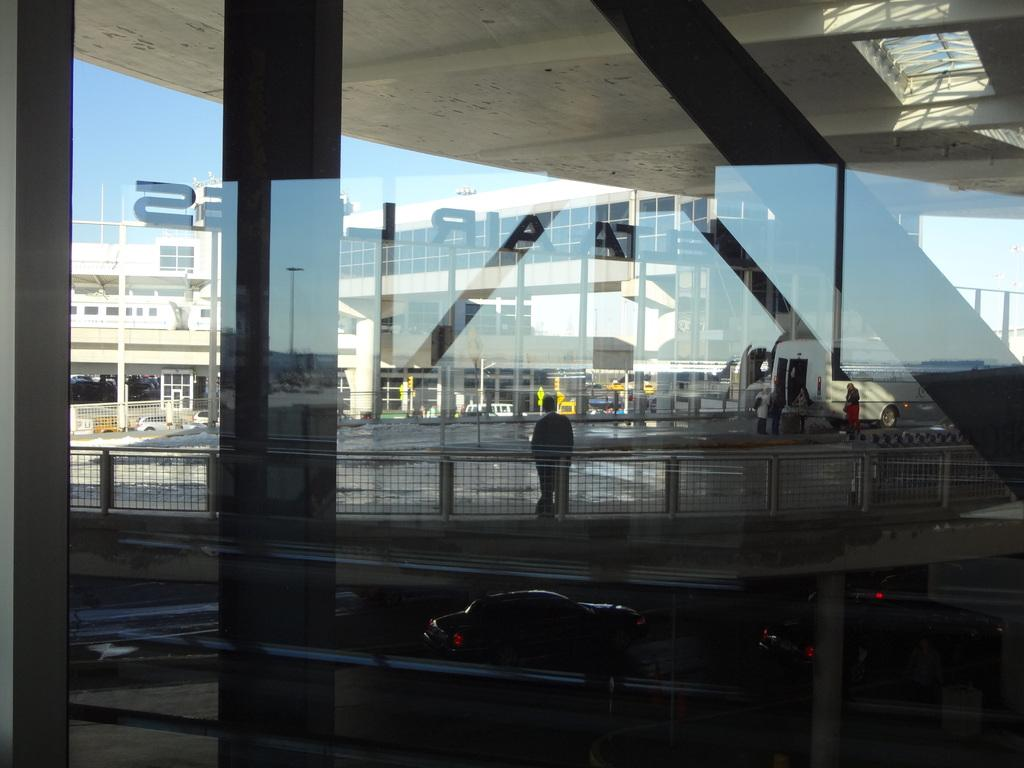What material is present in the image? There is glass in the image. What type of structures can be seen in the image? There are fences, vehicles, people, buildings, and objects in the image. What can be seen in the background of the image? The sky is visible in the background of the image. What type of hat is the glass wearing in the image? There is no hat present in the image, as the glass is an inanimate object and cannot wear a hat. 